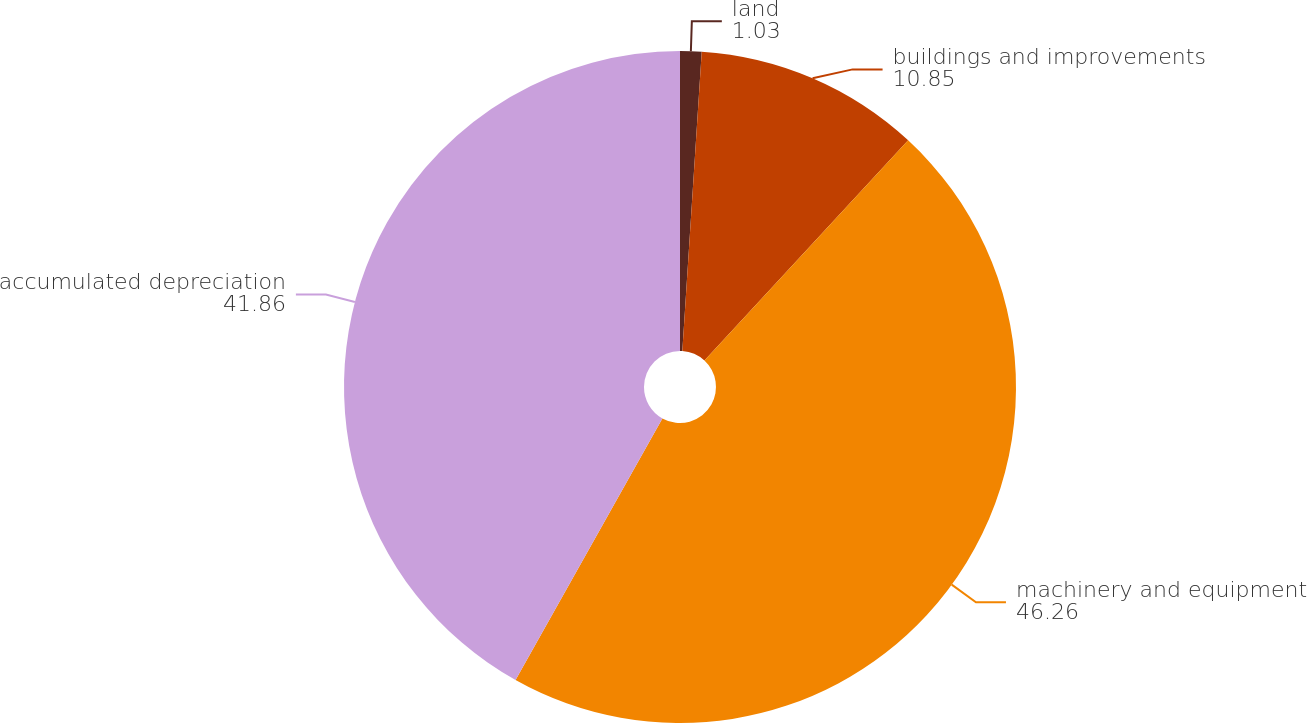Convert chart to OTSL. <chart><loc_0><loc_0><loc_500><loc_500><pie_chart><fcel>land<fcel>buildings and improvements<fcel>machinery and equipment<fcel>accumulated depreciation<nl><fcel>1.03%<fcel>10.85%<fcel>46.26%<fcel>41.86%<nl></chart> 